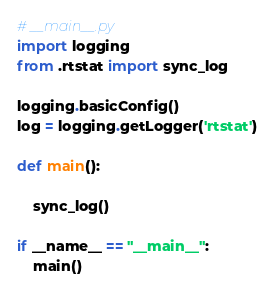Convert code to text. <code><loc_0><loc_0><loc_500><loc_500><_Python_># __main__.py
import logging
from .rtstat import sync_log

logging.basicConfig()
log = logging.getLogger('rtstat')

def main():

    sync_log()

if __name__ == "__main__":
    main()</code> 